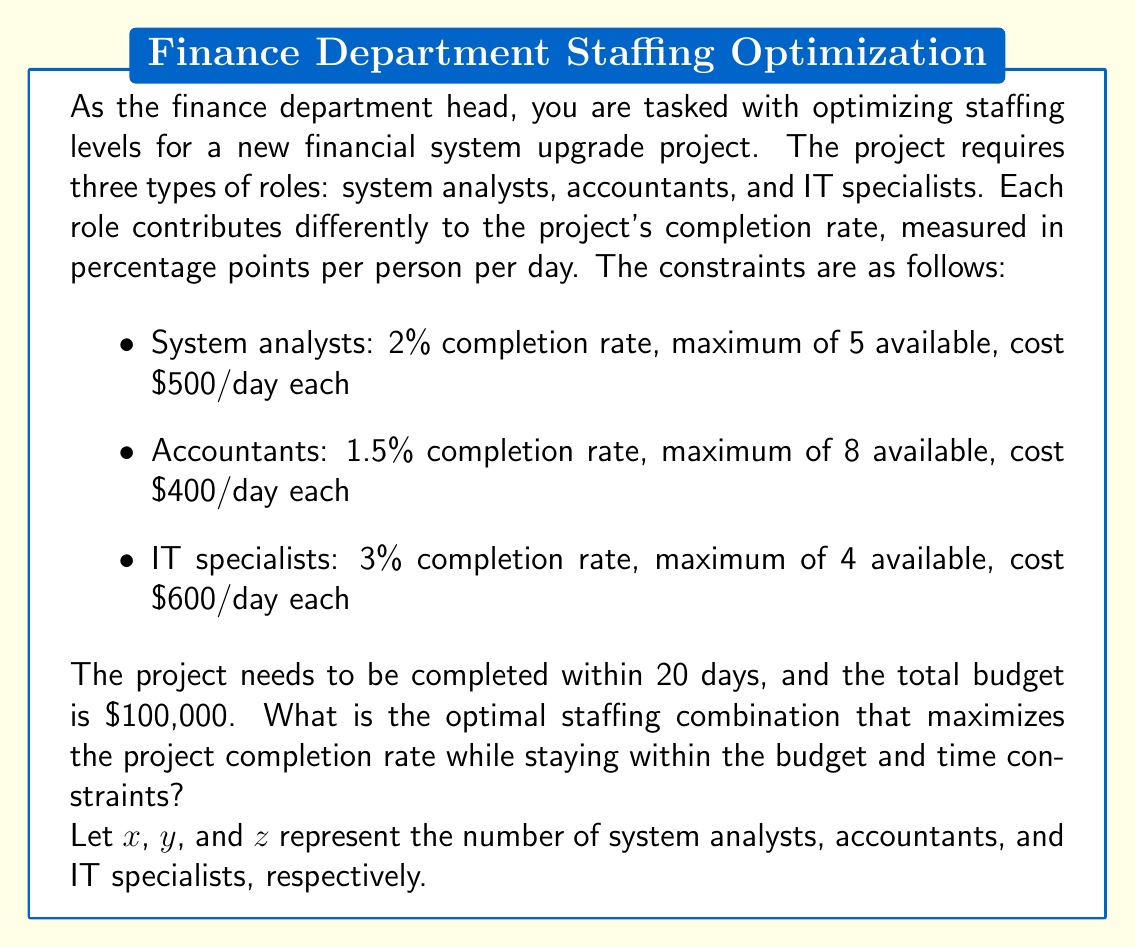Show me your answer to this math problem. To solve this optimization problem, we need to set up a linear programming model:

Objective function (maximize completion rate):
$$ \text{Maximize } 2x + 1.5y + 3z $$

Subject to the following constraints:

1. Budget constraint:
$$ 500x + 400y + 600z \leq 100,000 / 20 = 5,000 \text{ (daily budget)} $$

2. Time constraint (completion rate must be at least 100% over 20 days):
$$ 20(2x + 1.5y + 3z) \geq 100 $$
$$ 40x + 30y + 60z \geq 100 $$

3. Staff availability constraints:
$$ 0 \leq x \leq 5 $$
$$ 0 \leq y \leq 8 $$
$$ 0 \leq z \leq 4 $$

4. Integer constraints (we can't hire fractional employees):
$$ x, y, z \text{ are integers} $$

To solve this problem, we can use the simplex method with integer constraints. However, for this explanation, we'll use a systematic approach:

1. Start by maximizing the number of IT specialists (z) as they have the highest completion rate:
   $600z \leq 5,000$ gives us $z \leq 8.33$, but $z \leq 4$ due to availability constraint.
   So, we set $z = 4$.

2. Remaining daily budget: $5,000 - (600 * 4) = 2,600$

3. Now, we prioritize system analysts (x) over accountants:
   $500x \leq 2,600$ gives us $x \leq 5.2$, but $x \leq 5$ due to availability constraint.
   So, we set $x = 5$.

4. Remaining daily budget: $2,600 - (500 * 5) = 100$

5. For accountants (y):
   $400y \leq 100$ gives us $y \leq 0.25$
   We can't hire a fractional employee, so $y = 0$.

6. Check if this combination satisfies the time constraint:
   $40(5) + 30(0) + 60(4) = 440 \geq 100$, so it does.

7. Calculate the total completion rate:
   $2(5) + 1.5(0) + 3(4) = 22$ percentage points per day

This combination maximizes the completion rate while staying within all constraints.
Answer: The optimal staffing combination is:
- 5 system analysts
- 0 accountants
- 4 IT specialists

This combination yields a maximum completion rate of 22 percentage points per day. 